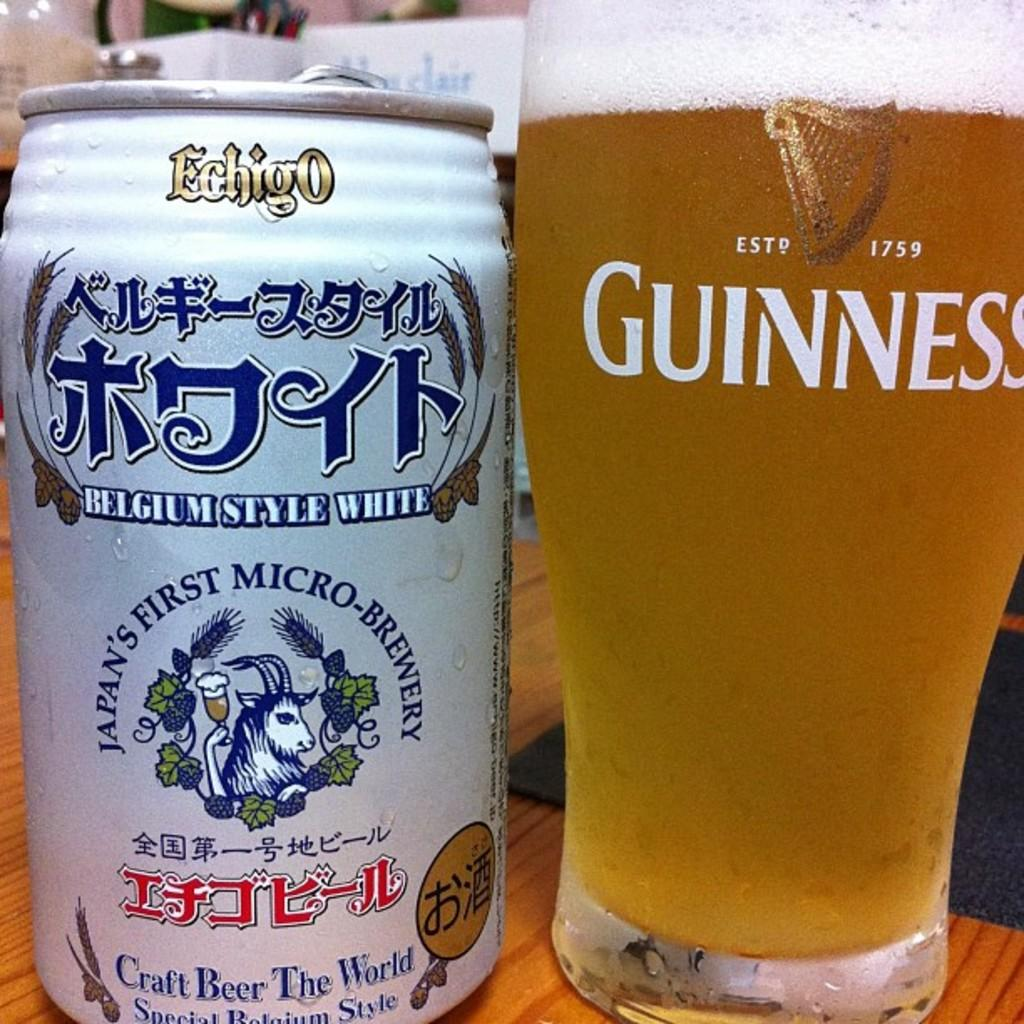<image>
Summarize the visual content of the image. A can of Japanese beer next to a glass of Guiness. 